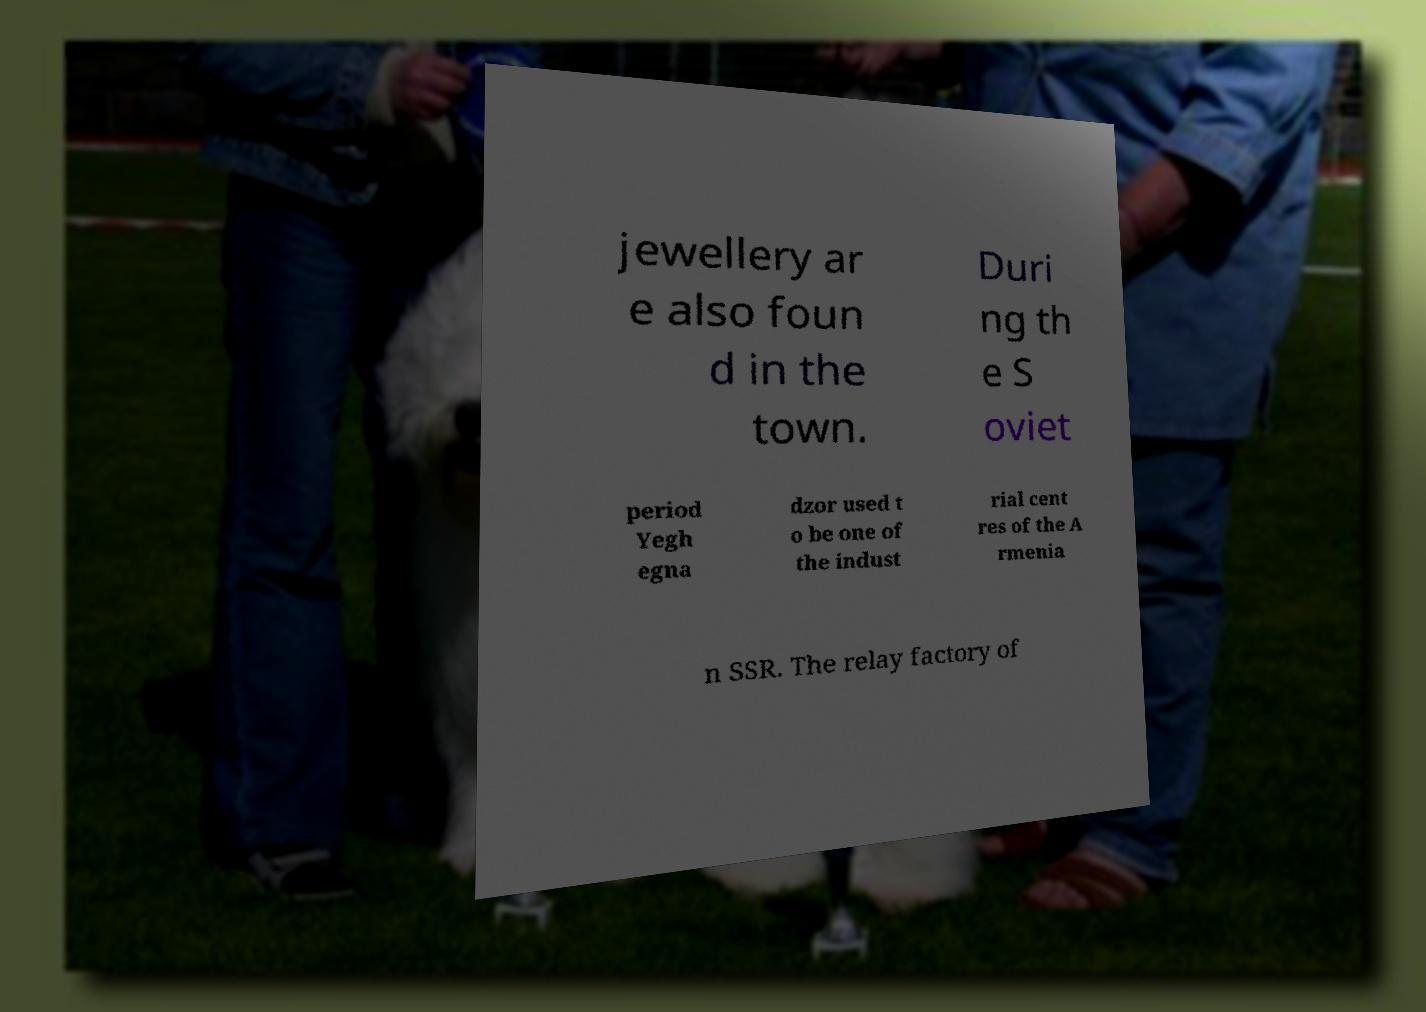Could you extract and type out the text from this image? jewellery ar e also foun d in the town. Duri ng th e S oviet period Yegh egna dzor used t o be one of the indust rial cent res of the A rmenia n SSR. The relay factory of 